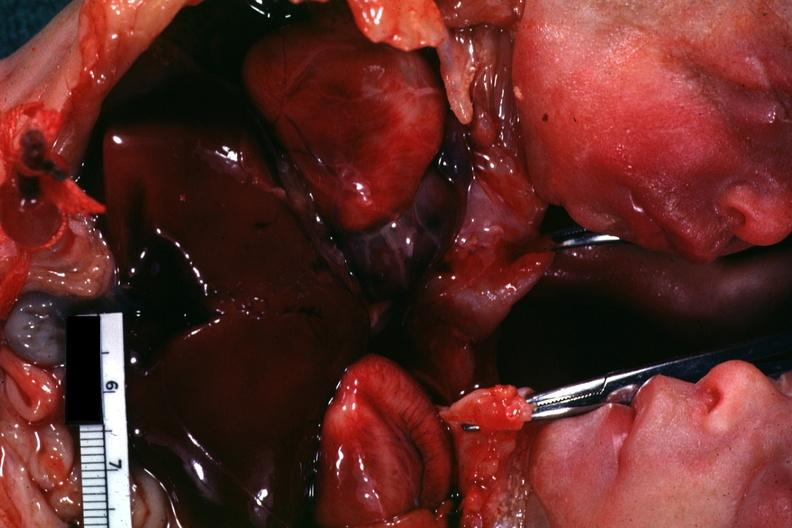s siamese twins present?
Answer the question using a single word or phrase. Yes 